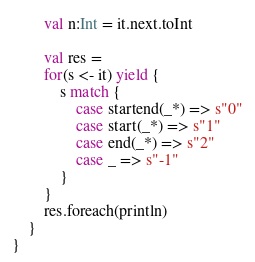Convert code to text. <code><loc_0><loc_0><loc_500><loc_500><_Scala_>        val n:Int = it.next.toInt

        val res =
        for(s <- it) yield {
            s match {
                case startend(_*) => s"0"
                case start(_*) => s"1"
                case end(_*) => s"2"
                case _ => s"-1"
            }
        }
        res.foreach(println)
    }
}
</code> 